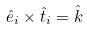Convert formula to latex. <formula><loc_0><loc_0><loc_500><loc_500>\hat { e } _ { i } \times \hat { t } _ { i } = \hat { k }</formula> 